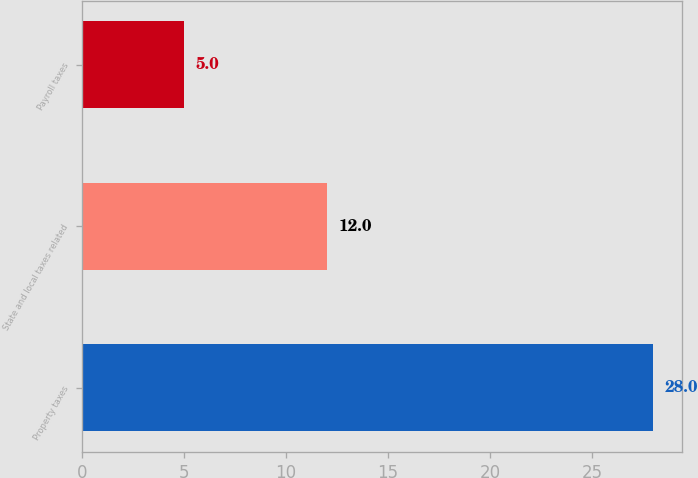<chart> <loc_0><loc_0><loc_500><loc_500><bar_chart><fcel>Property taxes<fcel>State and local taxes related<fcel>Payroll taxes<nl><fcel>28<fcel>12<fcel>5<nl></chart> 